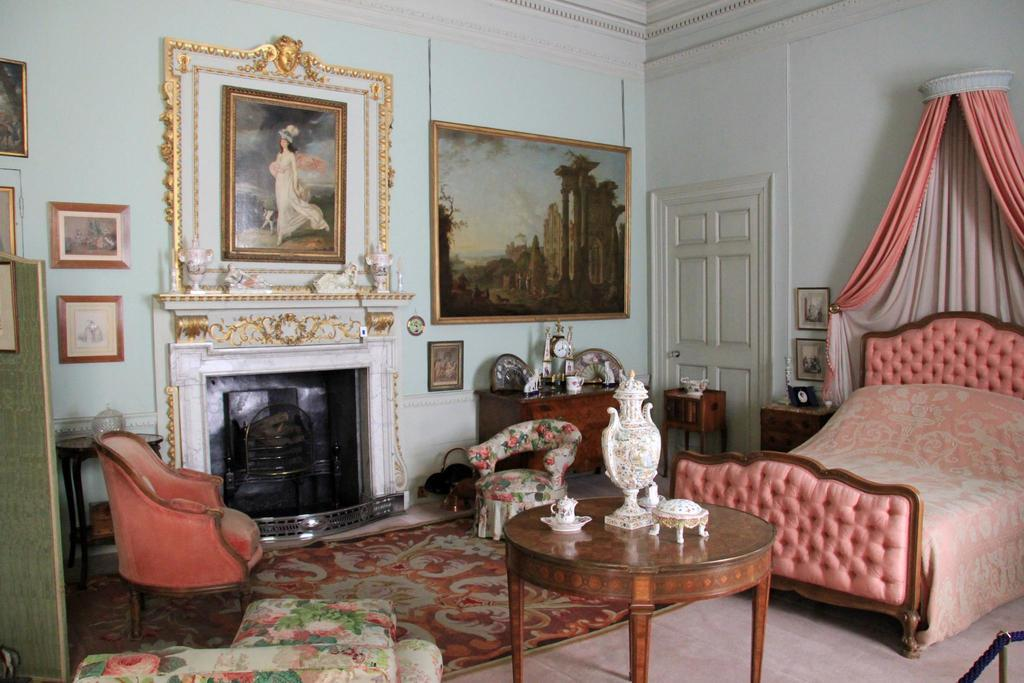What is hanging on the wall in the image? There are pictures on the wall. What type of flooring is present in the image? The floor has a carpet. What type of furniture is in the image? There is a bed and chairs in the image. What can be seen on the table in the image? There is a cup and a vase on the table, along with additional items. What type of feeling can be seen in the image? There is no feeling present in the image; it is a still picture of a room with various objects. Is there a net visible in the image? There is no net present in the image. 